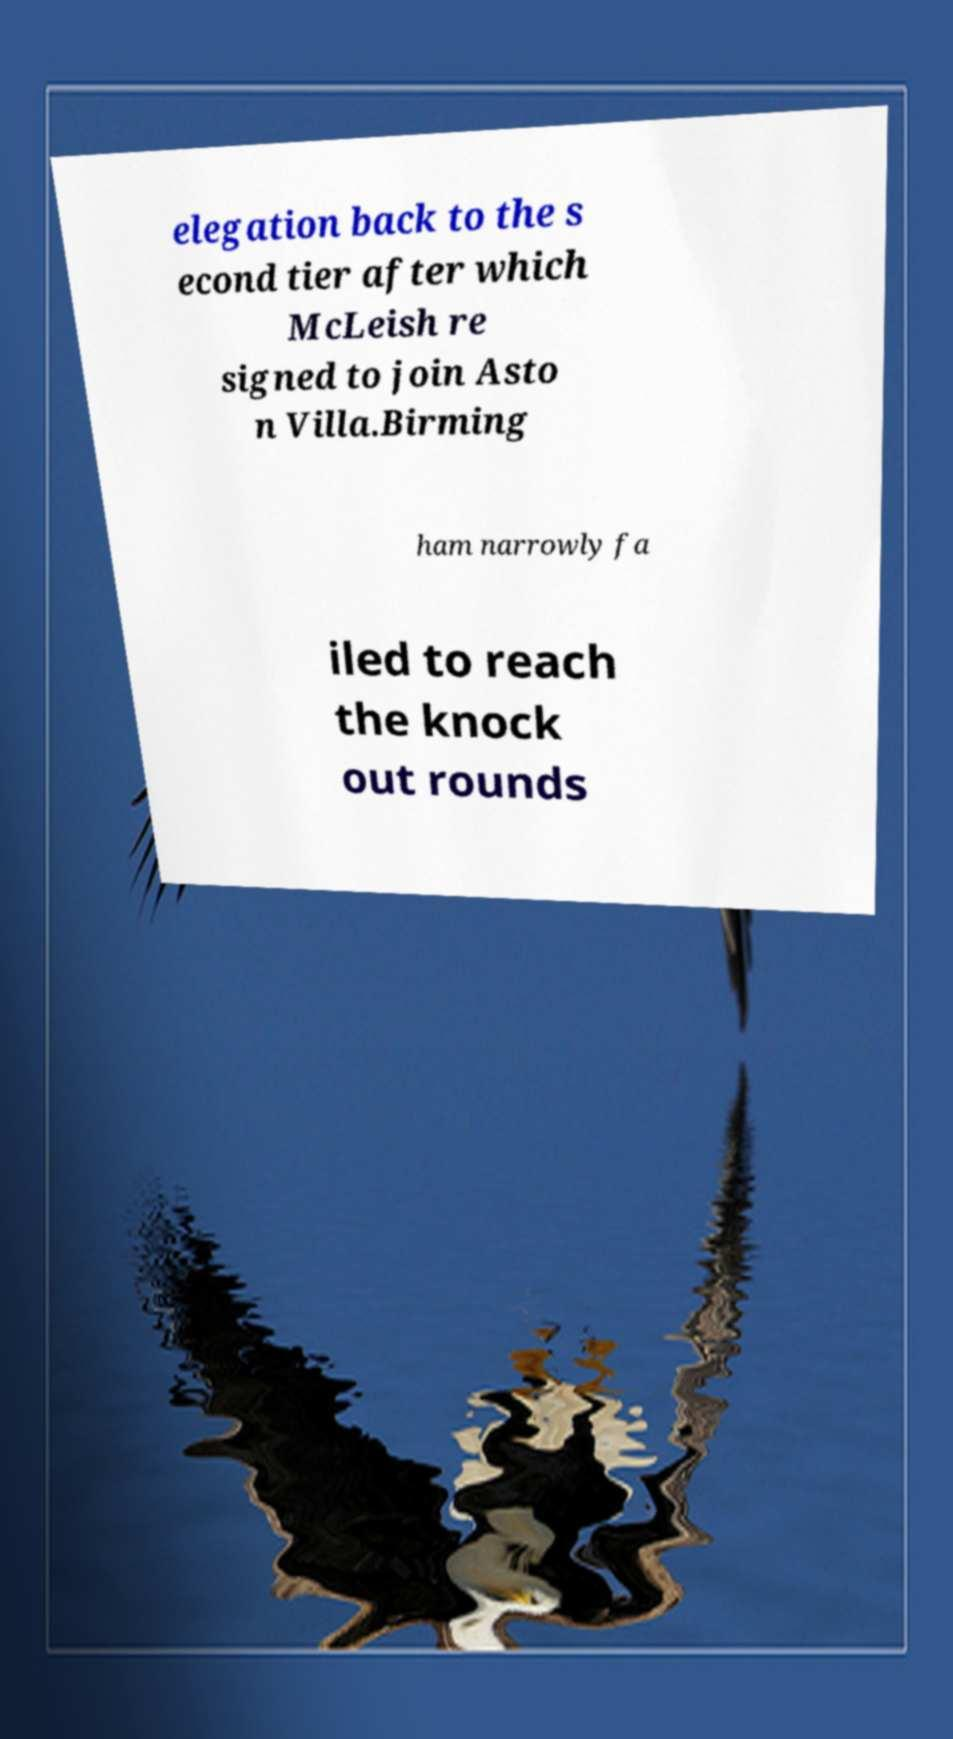What messages or text are displayed in this image? I need them in a readable, typed format. elegation back to the s econd tier after which McLeish re signed to join Asto n Villa.Birming ham narrowly fa iled to reach the knock out rounds 